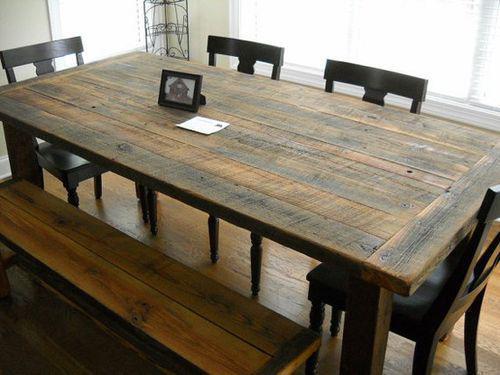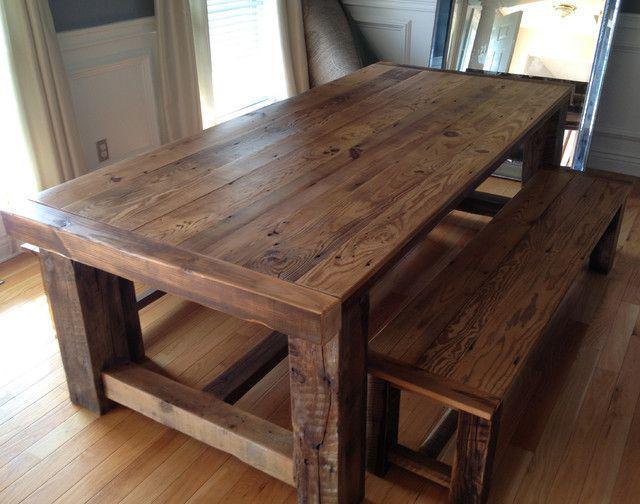The first image is the image on the left, the second image is the image on the right. Examine the images to the left and right. Is the description "A rectangular wooden dining table is shown with at least four chairs in one image." accurate? Answer yes or no. Yes. 